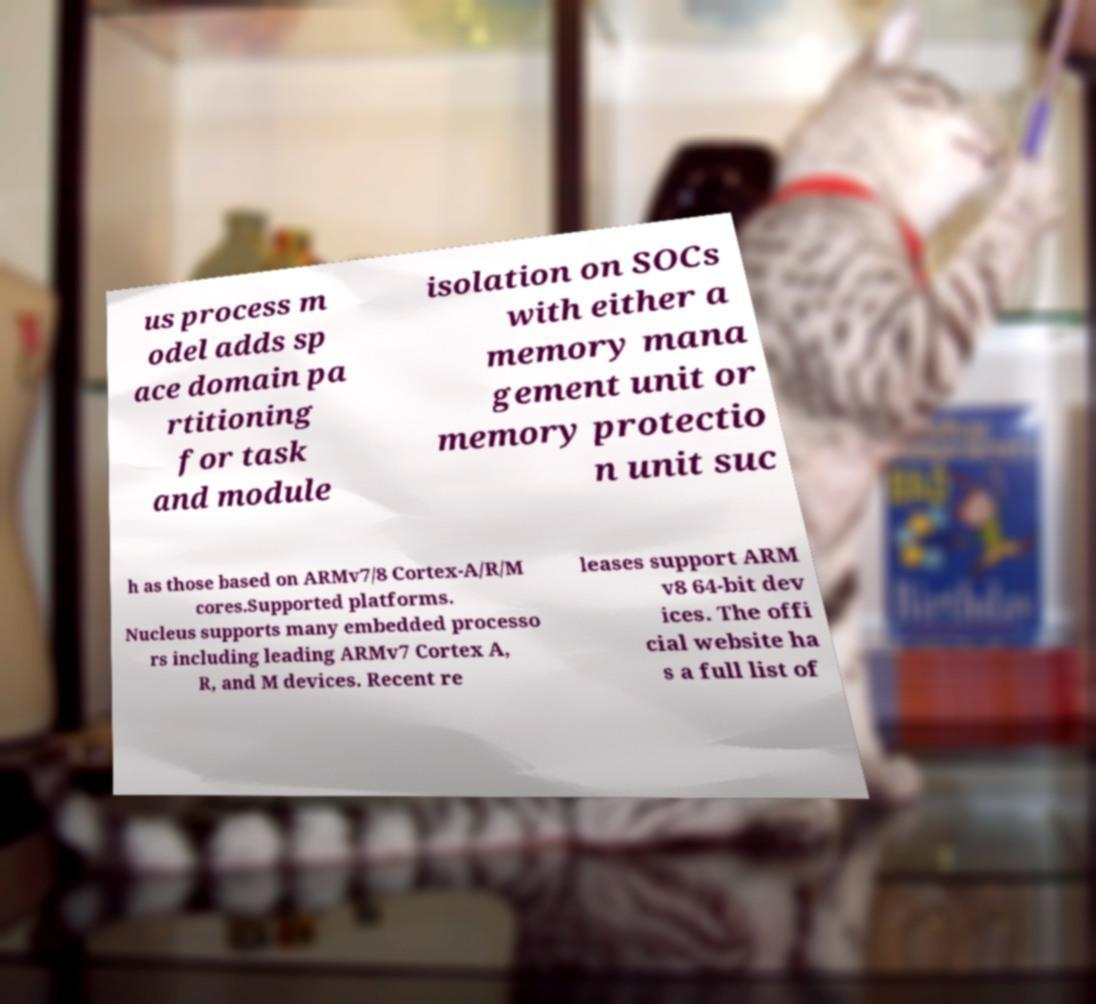Could you assist in decoding the text presented in this image and type it out clearly? us process m odel adds sp ace domain pa rtitioning for task and module isolation on SOCs with either a memory mana gement unit or memory protectio n unit suc h as those based on ARMv7/8 Cortex-A/R/M cores.Supported platforms. Nucleus supports many embedded processo rs including leading ARMv7 Cortex A, R, and M devices. Recent re leases support ARM v8 64-bit dev ices. The offi cial website ha s a full list of 